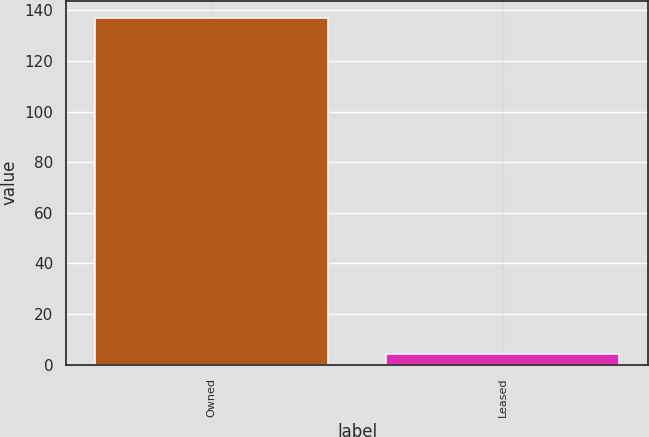<chart> <loc_0><loc_0><loc_500><loc_500><bar_chart><fcel>Owned<fcel>Leased<nl><fcel>137<fcel>4<nl></chart> 